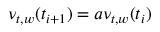Convert formula to latex. <formula><loc_0><loc_0><loc_500><loc_500>\nu _ { t , w } ( t _ { i + 1 } ) = a \nu _ { t , w } ( t _ { i } )</formula> 